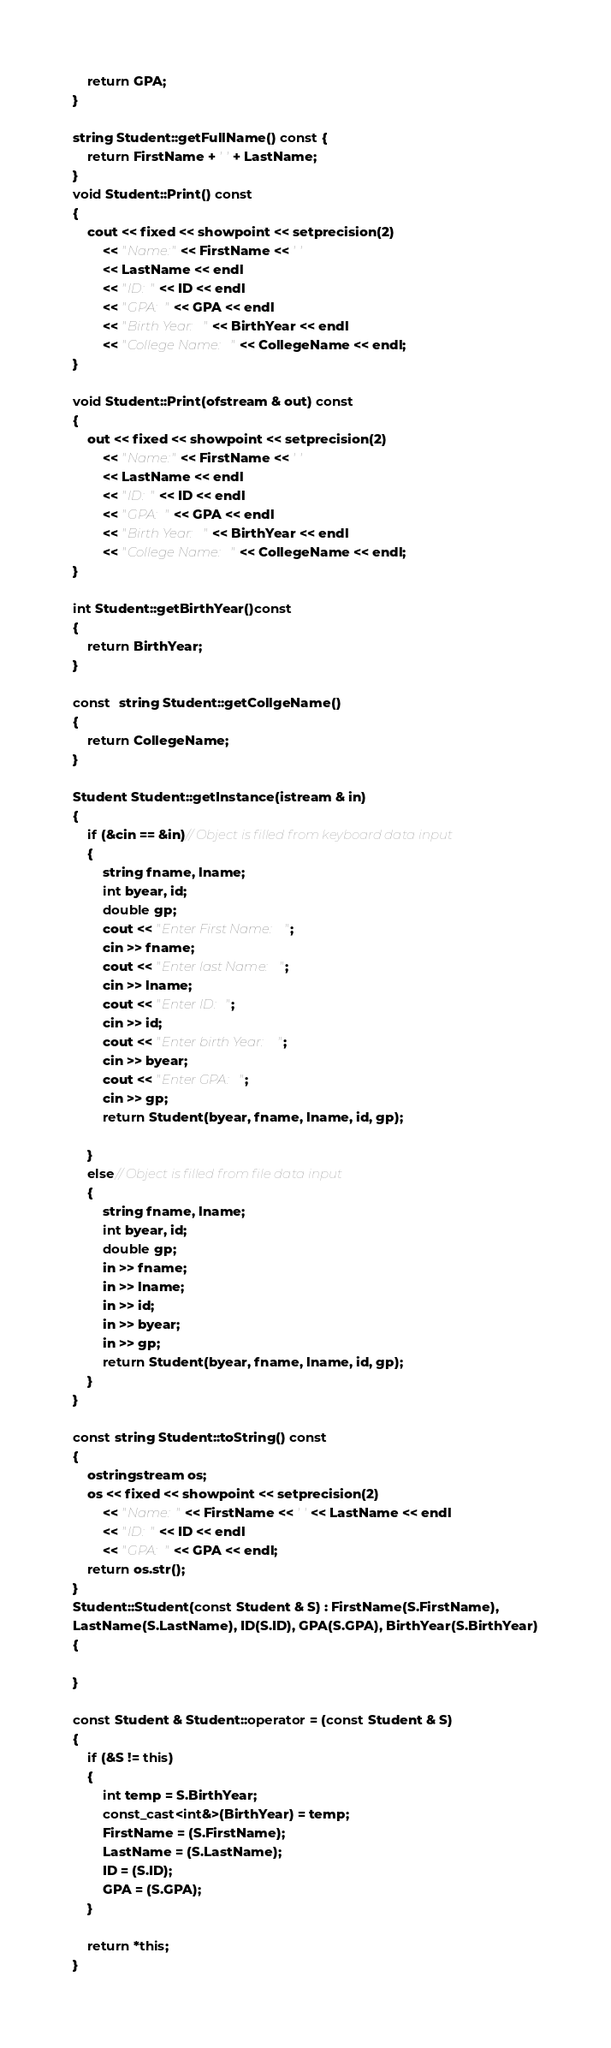Convert code to text. <code><loc_0><loc_0><loc_500><loc_500><_C++_>	return GPA;
}

string Student::getFullName() const {
	return FirstName + ' ' + LastName;
}
void Student::Print() const
{
	cout << fixed << showpoint << setprecision(2)
		<< "Name:" << FirstName << ' '
		<< LastName << endl
		<< "ID: " << ID << endl
		<< "GPA: " << GPA << endl
		<< "Birth Year: " << BirthYear << endl
		<< "College Name: " << CollegeName << endl;
}

void Student::Print(ofstream & out) const
{
	out << fixed << showpoint << setprecision(2)
		<< "Name:" << FirstName << ' '
		<< LastName << endl
		<< "ID: " << ID << endl
		<< "GPA: " << GPA << endl
		<< "Birth Year: " << BirthYear << endl
		<< "College Name: " << CollegeName << endl;
}

int Student::getBirthYear()const
{
	return BirthYear;
}

const  string Student::getCollgeName()
{
	return CollegeName;
}

Student Student::getInstance(istream & in)
{
	if (&cin == &in)// Object is filled from keyboard data input
	{
		string fname, lname;
		int byear, id;
		double gp;
		cout << "Enter First Name: ";
		cin >> fname;
		cout << "Enter last Name: ";
		cin >> lname;
		cout << "Enter ID: ";
		cin >> id;
		cout << "Enter birth Year: ";
		cin >> byear;
		cout << "Enter GPA: ";
		cin >> gp;
		return Student(byear, fname, lname, id, gp);

	}
	else// Object is filled from file data input
	{
		string fname, lname;
		int byear, id;
		double gp;
		in >> fname;
		in >> lname;
		in >> id;
		in >> byear;
		in >> gp;
		return Student(byear, fname, lname, id, gp);
	}
}

const string Student::toString() const
{
	ostringstream os;
	os << fixed << showpoint << setprecision(2)
		<< "Name: " << FirstName << ' ' << LastName << endl
		<< "ID: " << ID << endl
		<< "GPA: " << GPA << endl;
	return os.str();
}
Student::Student(const Student & S) : FirstName(S.FirstName),
LastName(S.LastName), ID(S.ID), GPA(S.GPA), BirthYear(S.BirthYear)
{
	
}

const Student & Student::operator = (const Student & S)
{
	if (&S != this)
	{
		int temp = S.BirthYear;
		const_cast<int&>(BirthYear) = temp;
		FirstName = (S.FirstName);
		LastName = (S.LastName);
		ID = (S.ID);
		GPA = (S.GPA);
	}

	return *this;
}</code> 